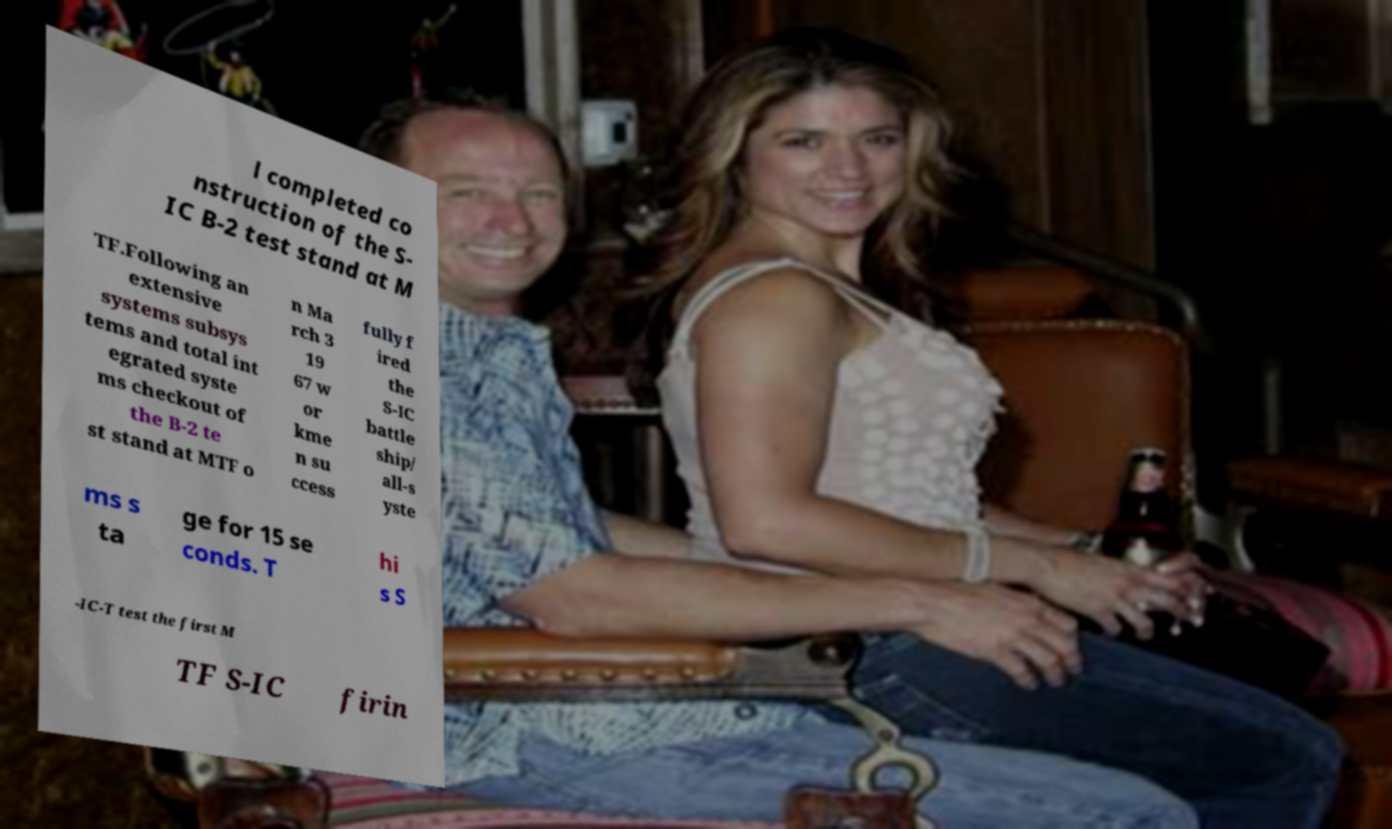Could you assist in decoding the text presented in this image and type it out clearly? l completed co nstruction of the S- IC B-2 test stand at M TF.Following an extensive systems subsys tems and total int egrated syste ms checkout of the B-2 te st stand at MTF o n Ma rch 3 19 67 w or kme n su ccess fully f ired the S-IC battle ship/ all-s yste ms s ta ge for 15 se conds. T hi s S -IC-T test the first M TF S-IC firin 